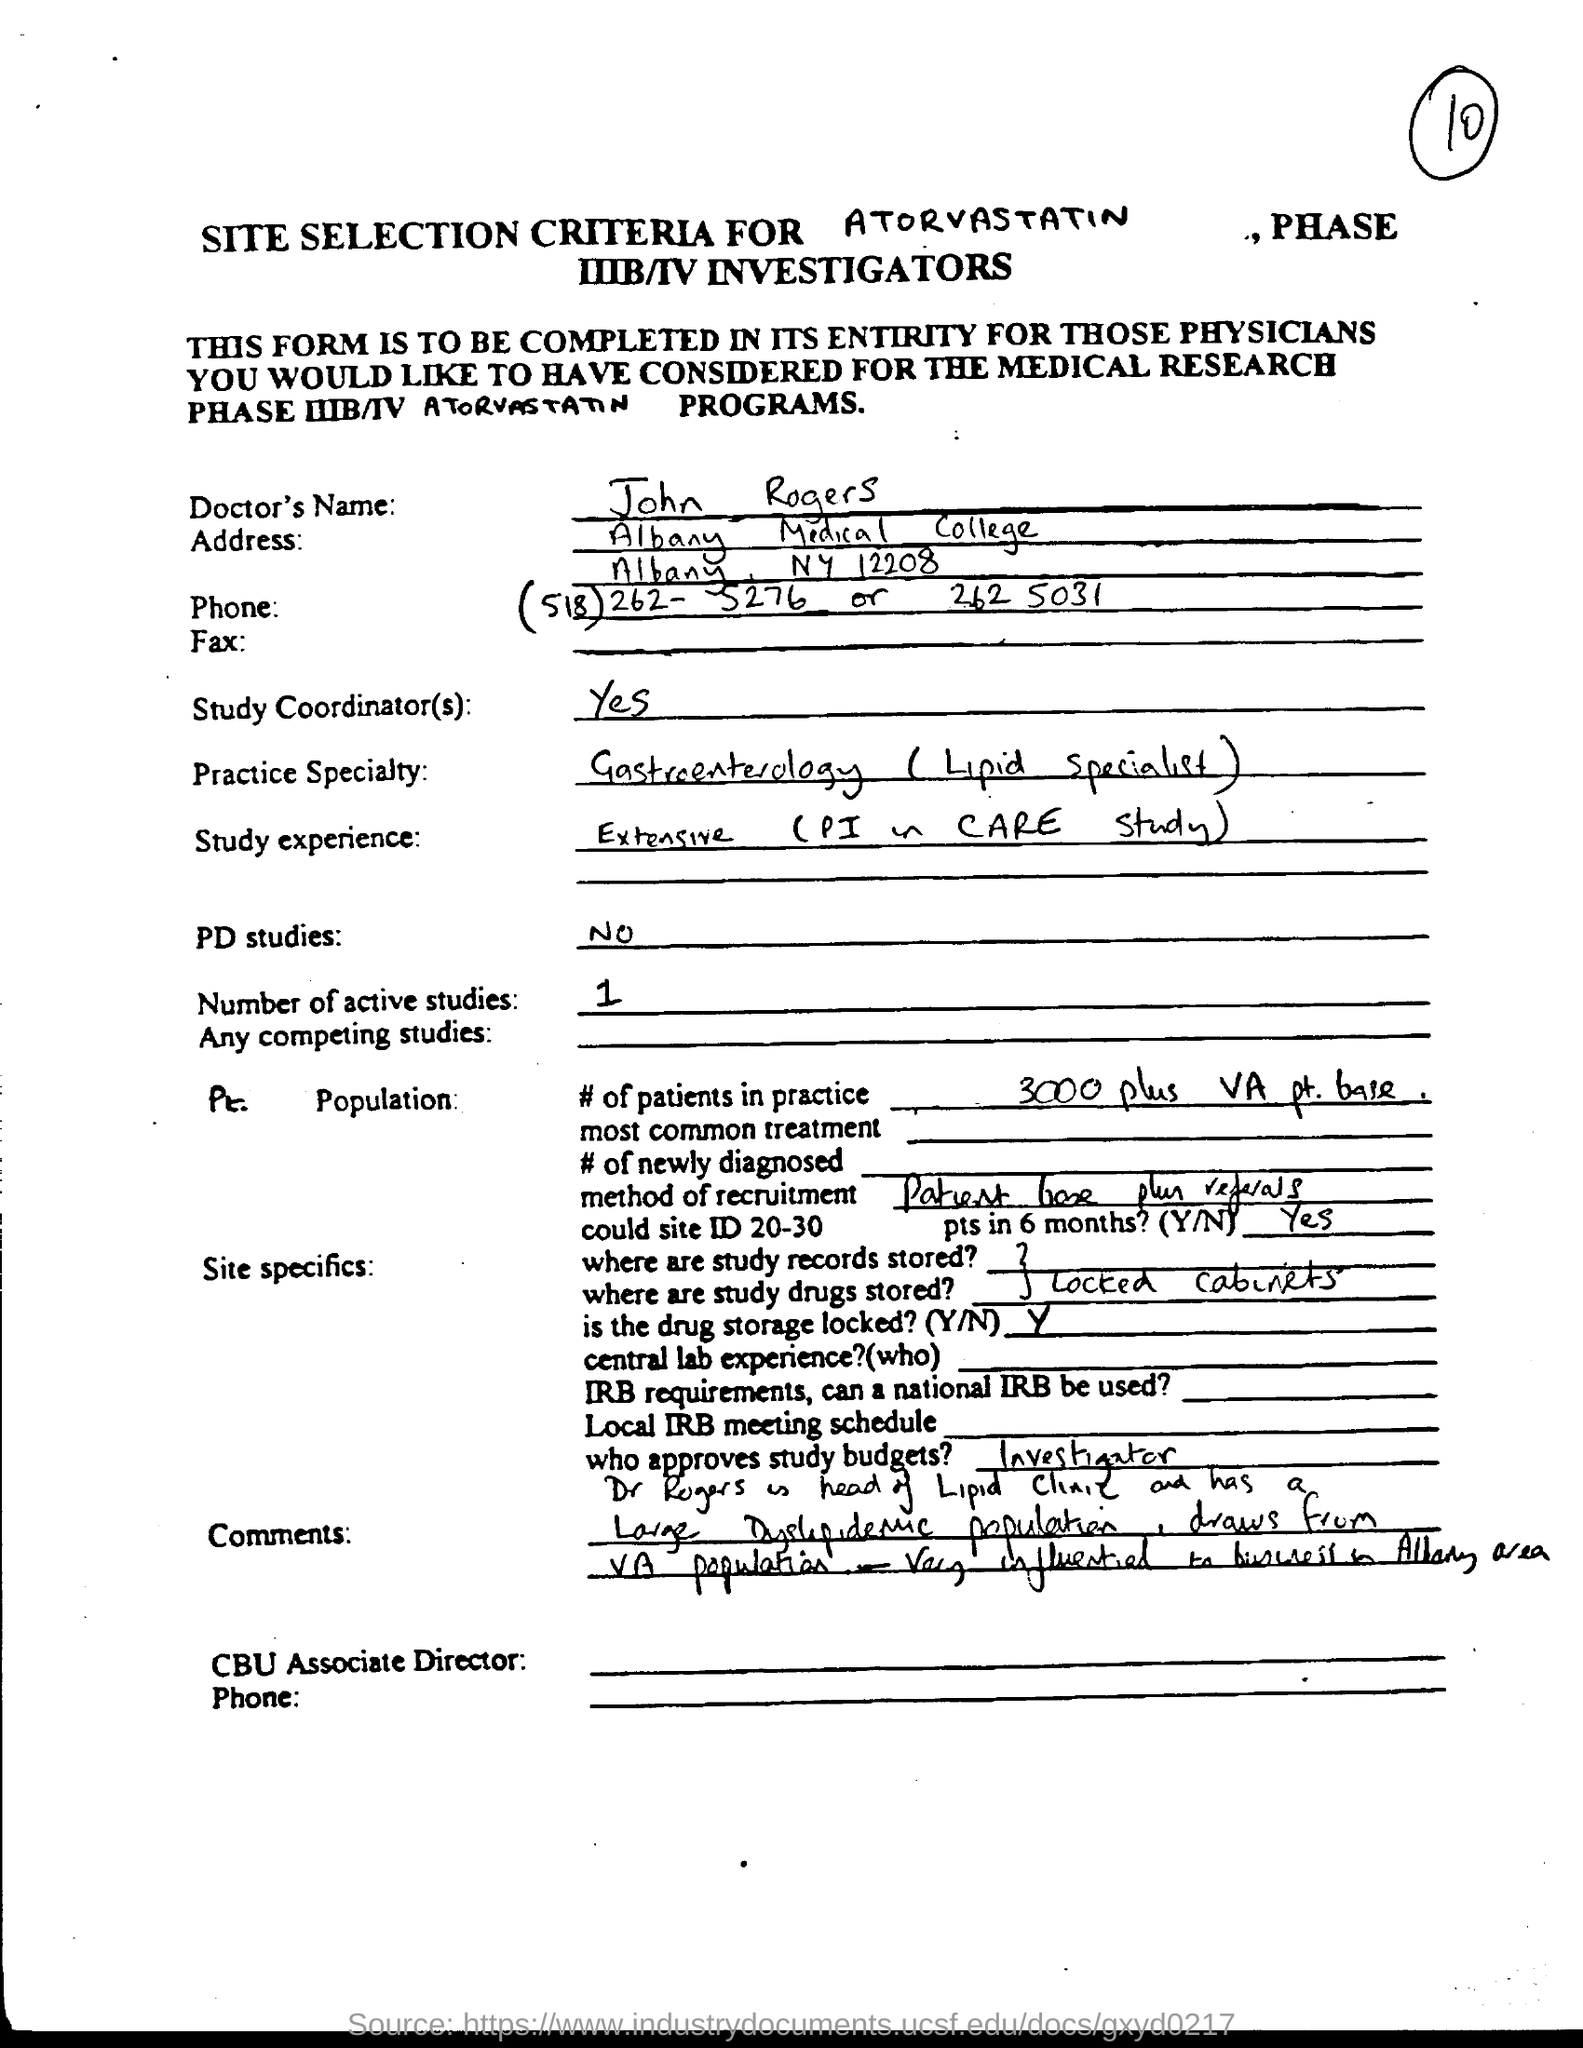Point out several critical features in this image. The Doctor's name is John Rogers. 